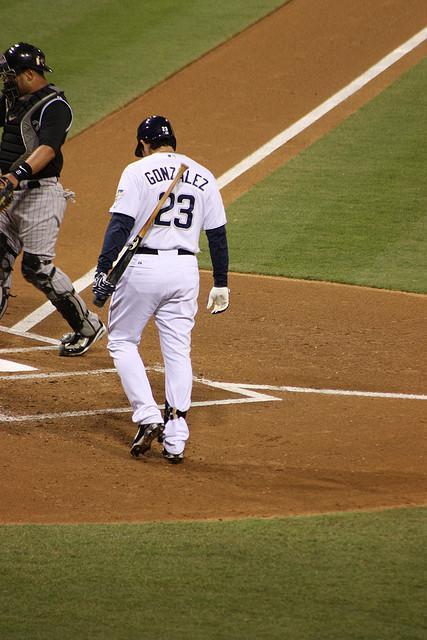How many players are in the picture?
Give a very brief answer. 2. How many people can be seen?
Give a very brief answer. 2. How many black cars are there?
Give a very brief answer. 0. 